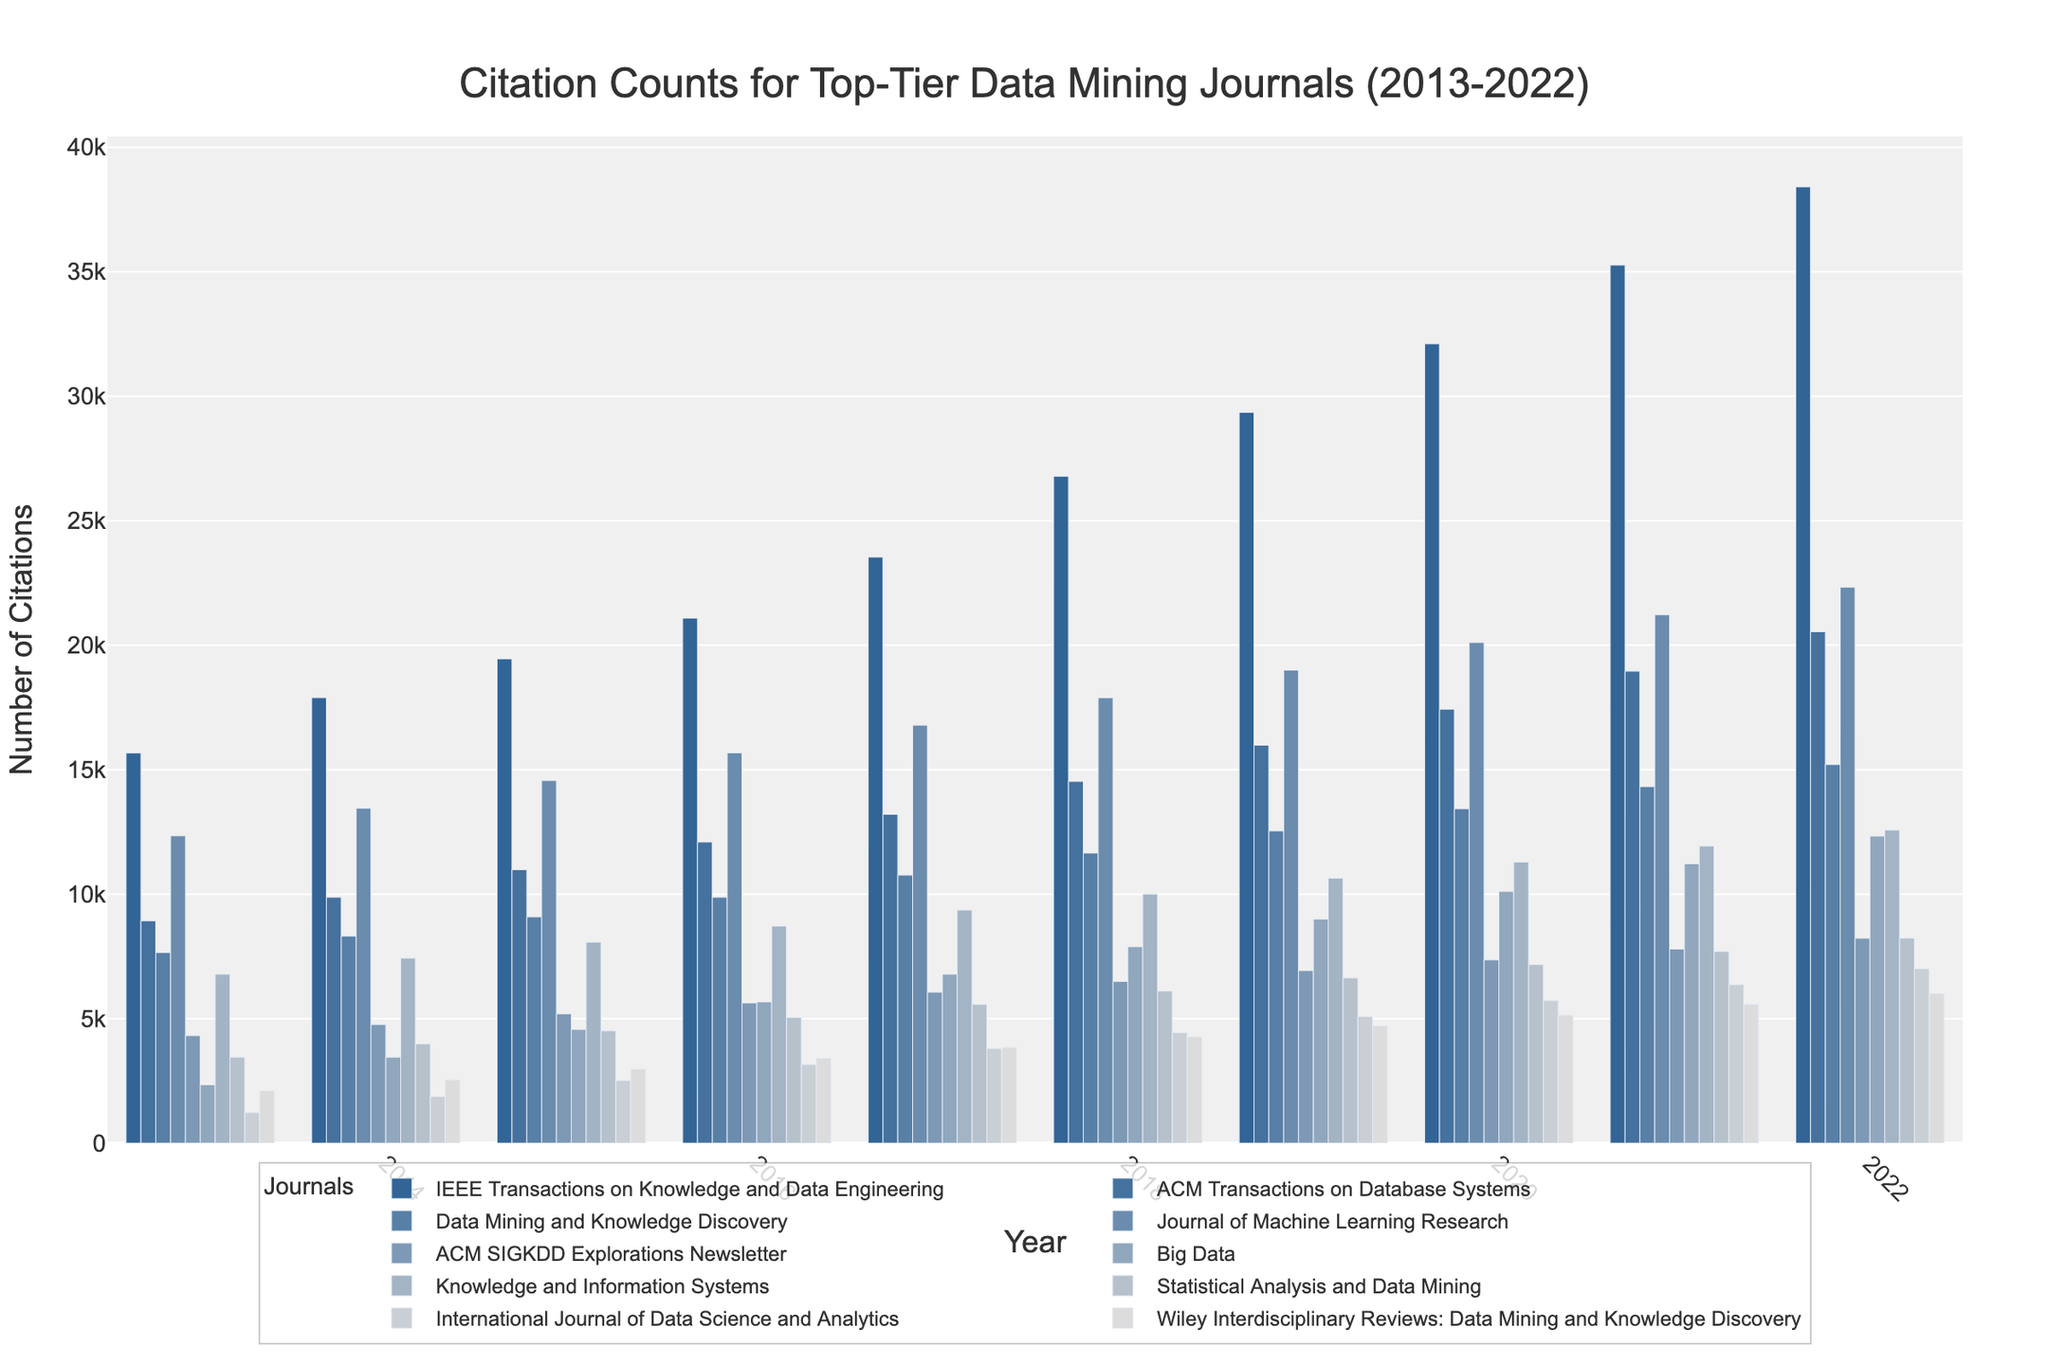What's the trend of citations for the 'IEEE Transactions on Knowledge and Data Engineering' from 2013 to 2022? The citations for 'IEEE Transactions on Knowledge and Data Engineering' have been steadily increasing every year from 15,672 in 2013 to 38,412 in 2022. To identify this, observe the increasing height of the bars corresponding to this journal year by year.
Answer: Increasing trend Which journal had the highest citation count in 2022? To find the journal with the highest citation count in 2022, look for the tallest bar in the 2022 section. 'IEEE Transactions on Knowledge and Data Engineering' has the highest citation count with 38,412 citations.
Answer: IEEE Transactions on Knowledge and Data Engineering How do citation counts of 'Big Data' compare between 2013 and 2022? In 2013, 'Big Data' had 2,345 citations. By 2022, this count increased to 12,334. Visually, locate the 2013 and 2022 bars corresponding to 'Big Data' and note the significant increase in height.
Answer: Increased What is the total number of citations for 'ACM Transactions on Database Systems' from 2013 to 2015? Sum the citations for 'ACM Transactions on Database Systems' for the years 2013 (8,934), 2014 (9,876), and 2015 (10,987). The calculation is 8,934 + 9,876 + 10,987 = 29,797.
Answer: 29,797 Which journal showed the most consistent growth in citations from 2013 to 2022? To identify the journal with the most consistent growth, look for the journal whose bars increase by a relatively steady amount each year. 'IEEE Transactions on Knowledge and Data Engineering' shows consistent growth every year.
Answer: IEEE Transactions on Knowledge and Data Engineering Between 2013 and 2022, which journal had the lowest overall citation count? To find the journal with the lowest overall citation count, sum the citations for each journal over the decade and identify the smallest total. 'International Journal of Data Science and Analytics' has the lowest overall citation count.
Answer: International Journal of Data Science and Analytics What is the average citation count for 'Journal of Machine Learning Research' in the first and last year depicted? Calculate the average of the citations for 'Journal of Machine Learning Research' in 2013 (12,345) and 2022 (22,334). The average is (12,345 + 22,334) / 2 = 17,339.5.
Answer: 17,339.5 By how much did the citation count for 'ACM SIGKDD Explorations Newsletter' increase from 2013 to 2022? Subtract the citation count of 'ACM SIGKDD Explorations Newsletter' in 2013 (4,321) from its citation count in 2022 (8,230). The increase is 8,230 - 4,321 = 3,909.
Answer: 3,909 Which year had the highest total citation count across all journals? Sum the citations for all journals for each year and identify the year with the highest total. For example, in 2022, sum all the journals' citations to get the total. The year with the highest total citation count overall is 2022.
Answer: 2022 